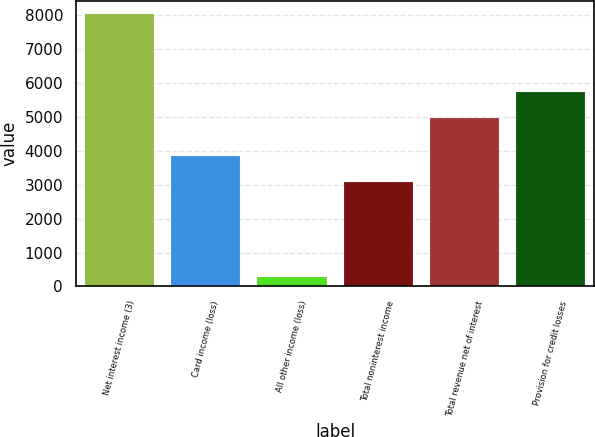Convert chart to OTSL. <chart><loc_0><loc_0><loc_500><loc_500><bar_chart><fcel>Net interest income (3)<fcel>Card income (loss)<fcel>All other income (loss)<fcel>Total noninterest income<fcel>Total revenue net of interest<fcel>Provision for credit losses<nl><fcel>8027<fcel>3841.9<fcel>288<fcel>3068<fcel>4959<fcel>5732.9<nl></chart> 